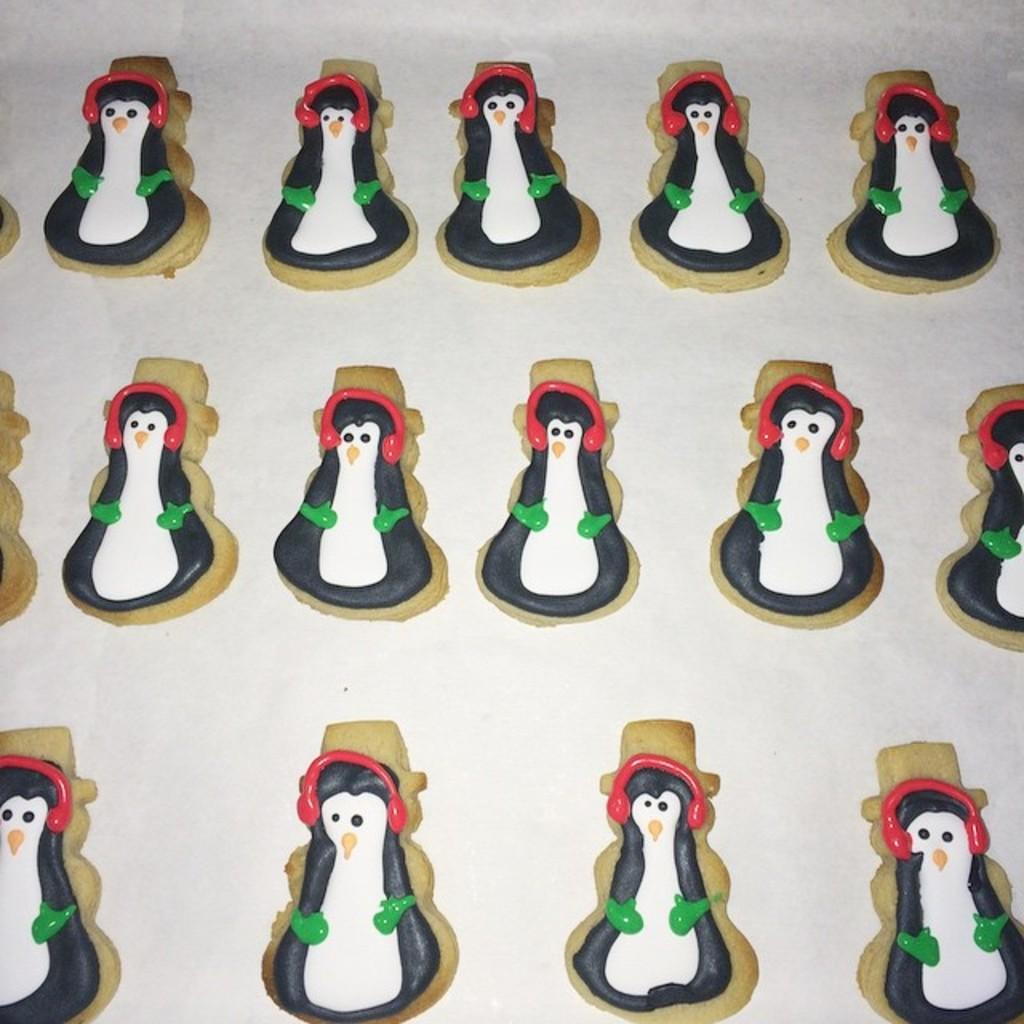What type of objects can be seen in the image? There are toys in the image. What material are the toys made of? The toys are made with clay. On what surface are the toys placed? The toys are placed on a white surface. What type of pets can be seen playing with the clay toys in the image? There are no pets present in the image, and the toys are not being played with. 